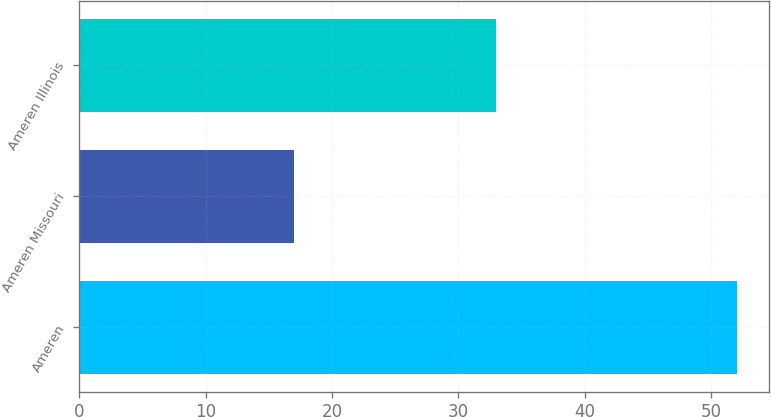Convert chart to OTSL. <chart><loc_0><loc_0><loc_500><loc_500><bar_chart><fcel>Ameren<fcel>Ameren Missouri<fcel>Ameren Illinois<nl><fcel>52<fcel>17<fcel>33<nl></chart> 